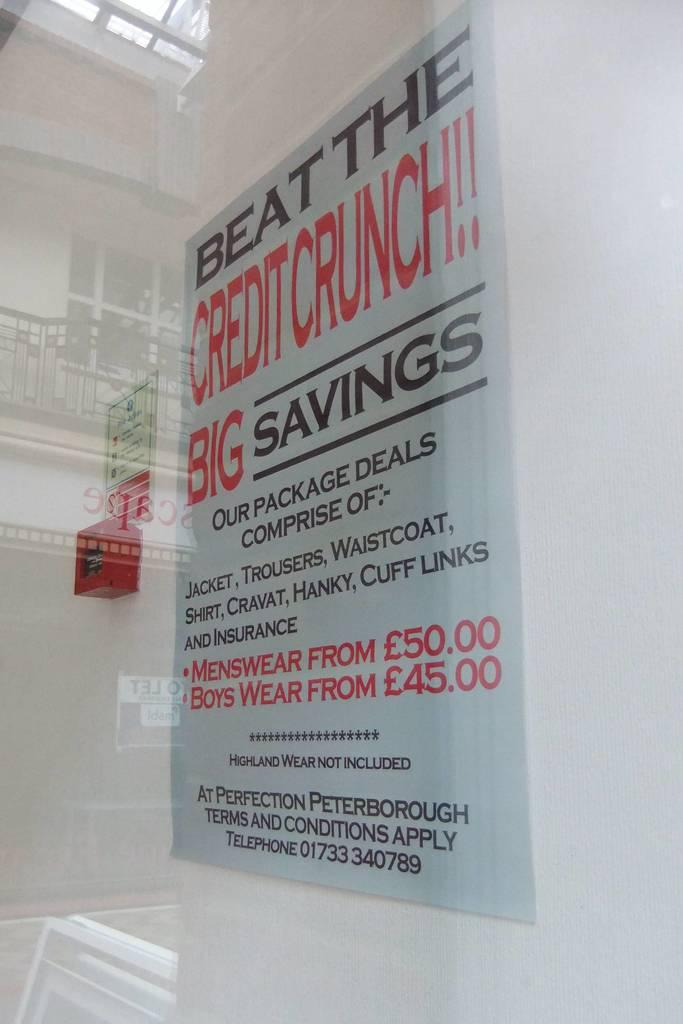Provide a one-sentence caption for the provided image. A sign that advertises savings at Perfection Peterborough. 